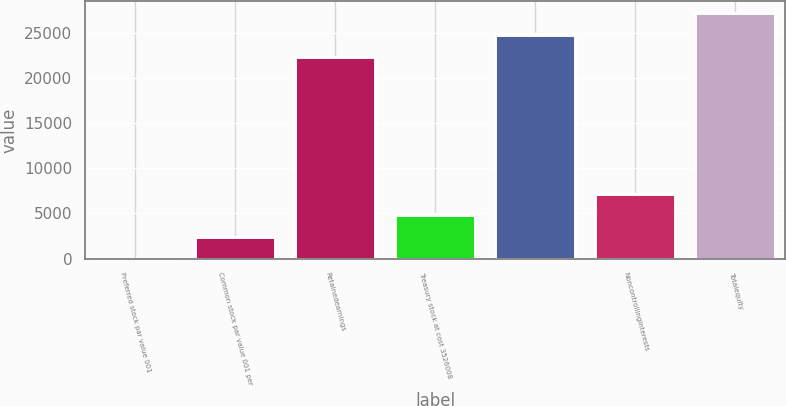Convert chart to OTSL. <chart><loc_0><loc_0><loc_500><loc_500><bar_chart><fcel>Preferred stock par value 001<fcel>Common stock par value 001 per<fcel>Retainedearnings<fcel>Treasury stock at cost 3526008<fcel>Unnamed: 4<fcel>Noncontrollinginterests<fcel>Totalequity<nl><fcel>1<fcel>2399.4<fcel>22403<fcel>4797.8<fcel>24801.4<fcel>7196.2<fcel>27199.8<nl></chart> 